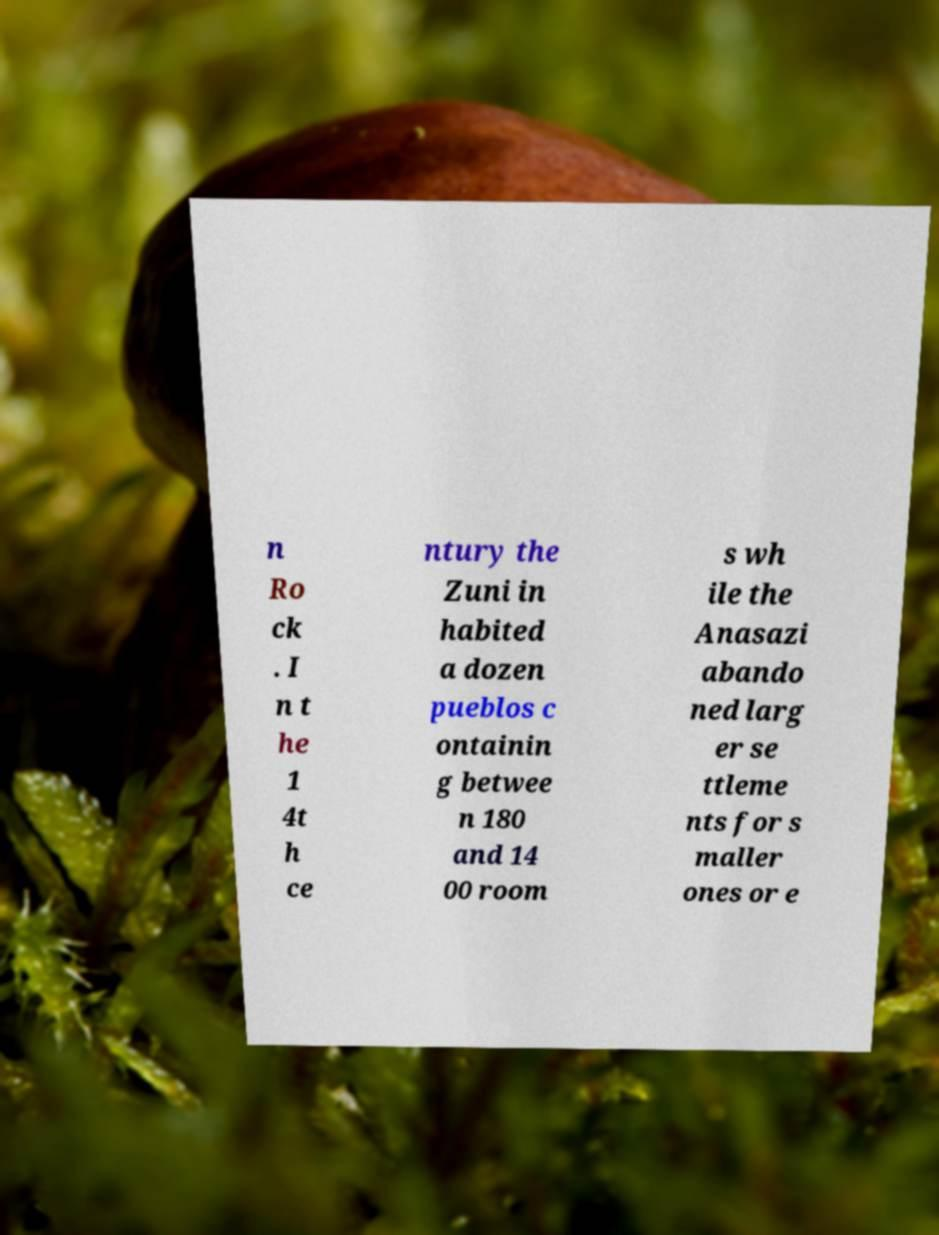Can you accurately transcribe the text from the provided image for me? n Ro ck . I n t he 1 4t h ce ntury the Zuni in habited a dozen pueblos c ontainin g betwee n 180 and 14 00 room s wh ile the Anasazi abando ned larg er se ttleme nts for s maller ones or e 